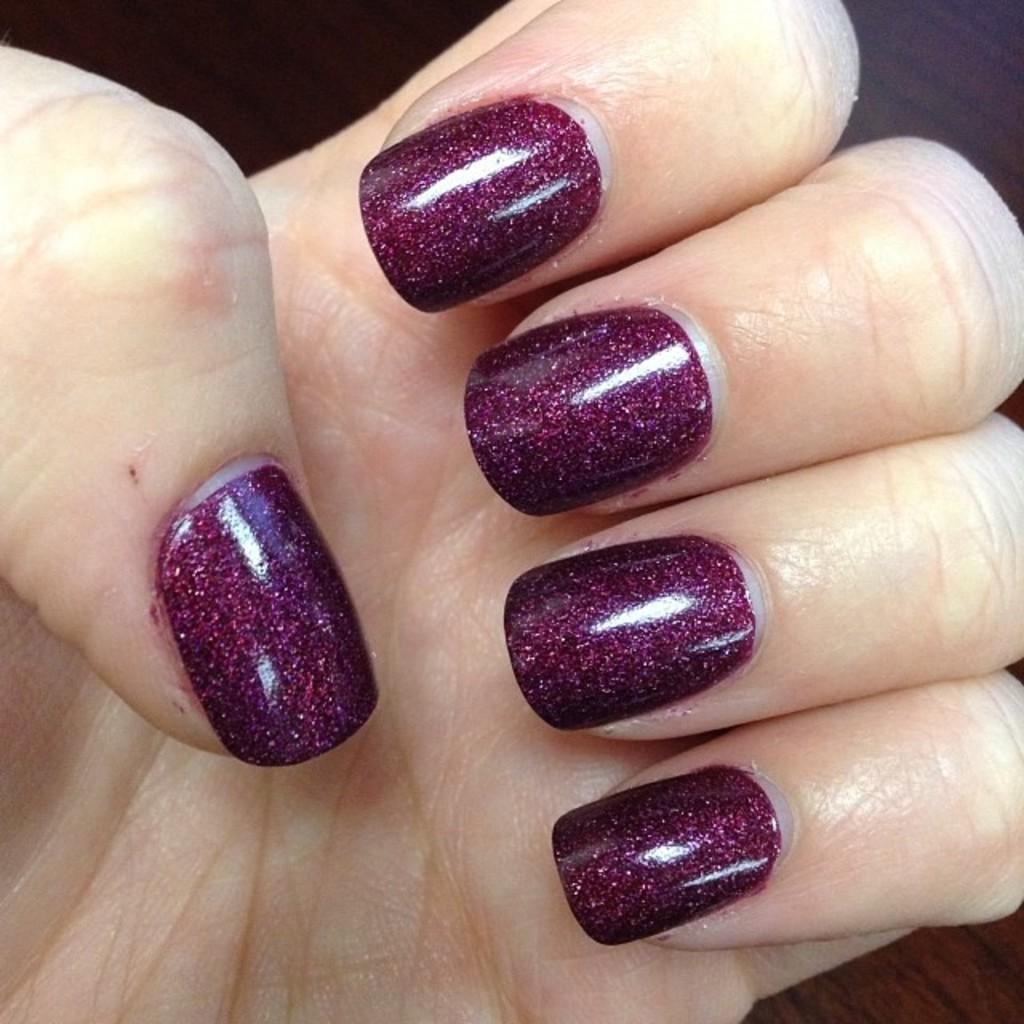Describe this image in one or two sentences. In this picture we can see fingers of a person, and also we can find nail polish. 